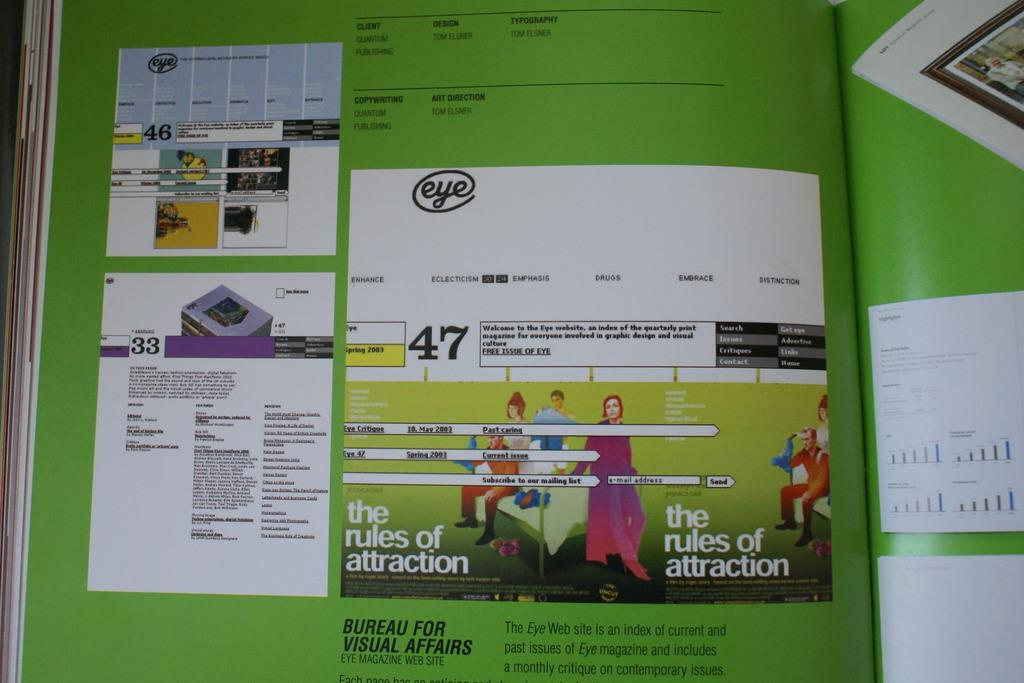<image>
Present a compact description of the photo's key features. The page of a book that says the rules of attraction on it. 